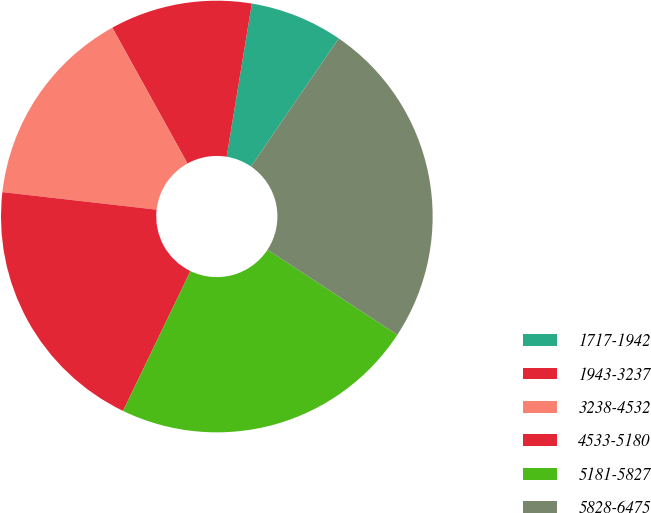<chart> <loc_0><loc_0><loc_500><loc_500><pie_chart><fcel>1717-1942<fcel>1943-3237<fcel>3238-4532<fcel>4533-5180<fcel>5181-5827<fcel>5828-6475<nl><fcel>6.96%<fcel>10.64%<fcel>15.15%<fcel>19.65%<fcel>22.92%<fcel>24.68%<nl></chart> 